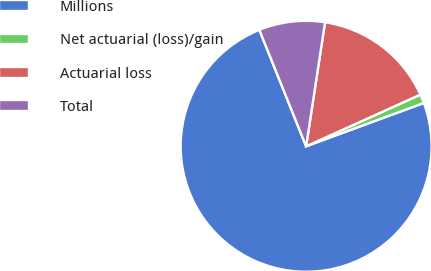Convert chart. <chart><loc_0><loc_0><loc_500><loc_500><pie_chart><fcel>Millions<fcel>Net actuarial (loss)/gain<fcel>Actuarial loss<fcel>Total<nl><fcel>74.54%<fcel>1.15%<fcel>15.83%<fcel>8.49%<nl></chart> 